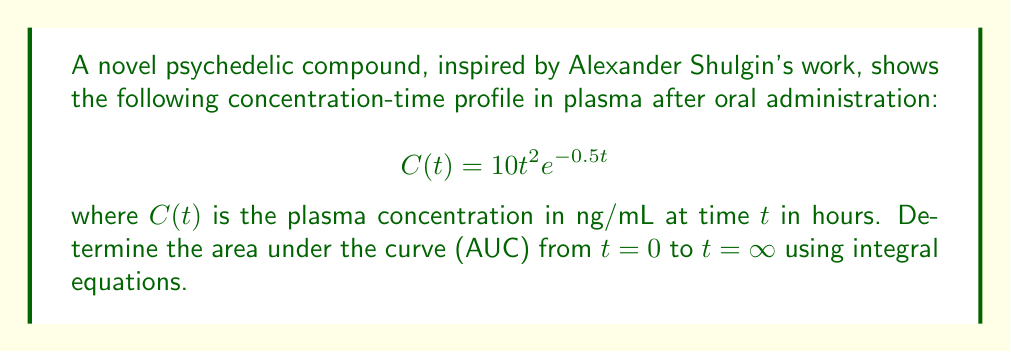Could you help me with this problem? To determine the area under the curve (AUC) from $t=0$ to $t=\infty$, we need to integrate the concentration-time function $C(t)$ over this interval:

$$AUC = \int_0^\infty C(t) dt = \int_0^\infty 10t^2e^{-0.5t} dt$$

Let's solve this integral step by step:

1) First, we can factor out the constant 10:
   $$AUC = 10 \int_0^\infty t^2e^{-0.5t} dt$$

2) This integral can be solved using integration by parts twice. Let $u = t^2$ and $dv = e^{-0.5t}dt$. Then:
   $$du = 2t dt$$
   $$v = -2e^{-0.5t}$$

3) Applying integration by parts:
   $$\int_0^\infty t^2e^{-0.5t} dt = -2t^2e^{-0.5t}\bigg|_0^\infty + \int_0^\infty 4te^{-0.5t} dt$$

4) The first term evaluates to 0 at both limits. For the second integral, we apply integration by parts again. Let $u = t$ and $dv = e^{-0.5t}dt$:
   $$du = dt$$
   $$v = -2e^{-0.5t}$$

5) This gives:
   $$\int_0^\infty 4te^{-0.5t} dt = -8te^{-0.5t}\bigg|_0^\infty + \int_0^\infty 8e^{-0.5t} dt$$

6) Again, the first term evaluates to 0 at both limits. The last integral is straightforward:
   $$\int_0^\infty 8e^{-0.5t} dt = -16e^{-0.5t}\bigg|_0^\infty = 16$$

7) Putting it all together and multiplying by 10:
   $$AUC = 10 \times 16 = 160$$

Therefore, the area under the curve from $t=0$ to $t=\infty$ is 160 ng⋅h/mL.
Answer: 160 ng⋅h/mL 